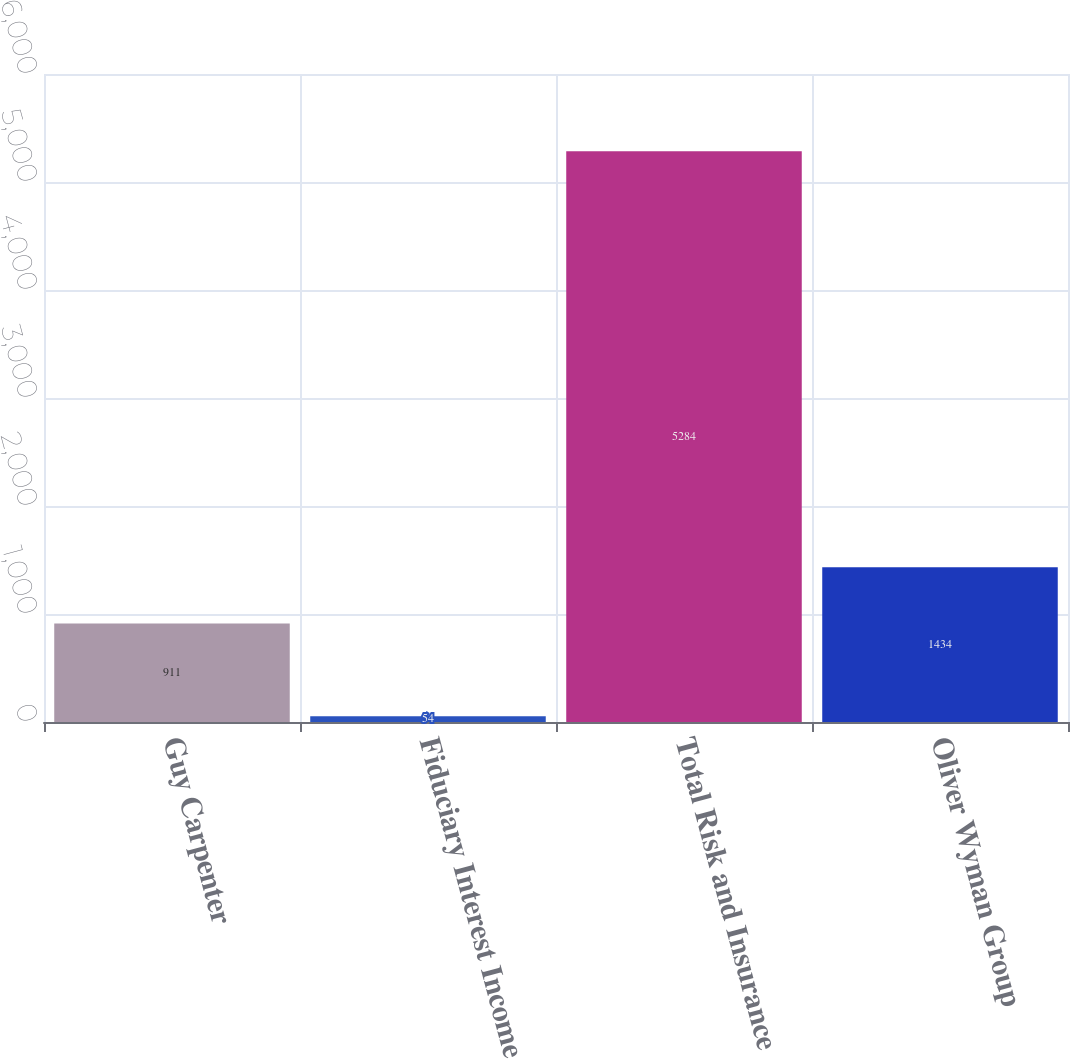Convert chart to OTSL. <chart><loc_0><loc_0><loc_500><loc_500><bar_chart><fcel>Guy Carpenter<fcel>Fiduciary Interest Income<fcel>Total Risk and Insurance<fcel>Oliver Wyman Group<nl><fcel>911<fcel>54<fcel>5284<fcel>1434<nl></chart> 